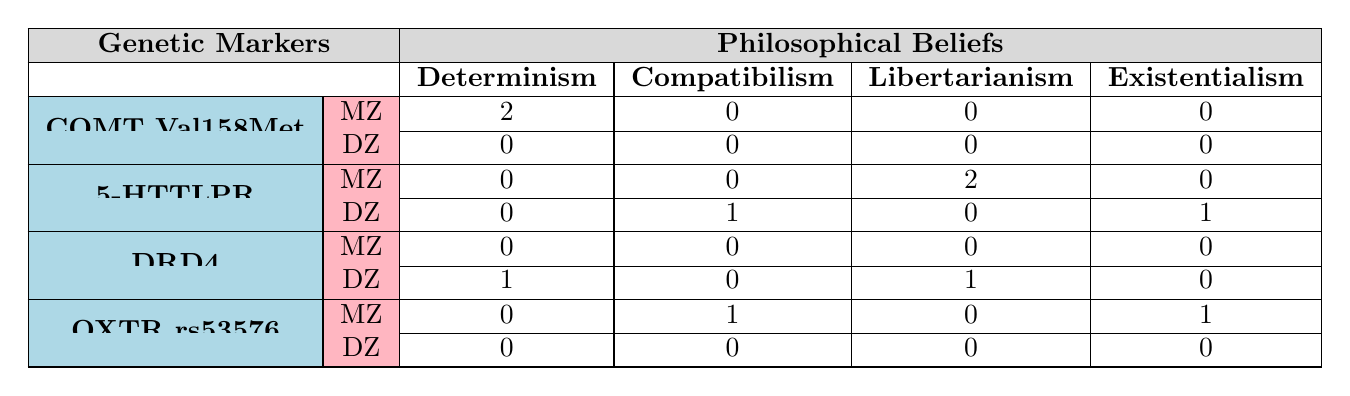What is the count of twin pairs for the genetic marker COMT Val158Met? The table shows that there are 2 twin pairs (both monozygotic) who have the philosophical belief of Determinism associated with the genetic marker COMT Val158Met.
Answer: 2 How many twin pairs subscribe to Compatibilism among twin pairs with the genetic marker OXTR rs53576? According to the table, there is 1 monozygotic twin pair that has a philosophical belief of Compatibilism with the genetic marker OXTR rs53576.
Answer: 1 What is the total number of twin pairs for the 5-HTTLPR genetic marker? The table indicates that there are 2 monozygotic twin pairs who believe in Libertarianism, and there is 1 dizygotic twin pair who holds Compatibilism and 1 who believes in Existentialism, making a total of 4 for the genetic marker 5-HTTLPR.
Answer: 4 Does any dizygotic twin pair have the same philosophical belief associated with the genetic marker DRD4? The table shows that there are no dizygotic twin pairs with the same philosophical belief associated with the genetic marker DRD4 as one holds Determinism and another holds Libertarianism.
Answer: No Which philosophical belief is most associated with monozygotic twins for the genetic marker 5-HTTLPR? The data shows that Libertarianism is the only philosophical belief reported among monozygotic twins for the genetic marker 5-HTTLPR, with 2 occurrences.
Answer: Libertarianism How many twin pairs with the genetic marker OXTR rs53576 are divided in their philosophical beliefs? For OXTR rs53576, there is 1 monozygotic twin pair divided between Compatibilism and Existentialism, showing a difference in belief.
Answer: 1 What is the relationship between genetic markers and the belief in Libertarianism across all twin pairs? Libertarianism appears twice in the monozygotic twins for the genetic marker 5-HTTLPR and once in the dizygotic twin for the marker DRD4, indicating a possible positive association, but only within the available data.
Answer: Positive association Is there any philosophical belief that is only found among dizygotic twins? The table shows that there are no philosophical beliefs exclusively found among dizygotic twins since all beliefs appear in at least one instance alongside monozygotic twins.
Answer: No What is the overall trend in philosophical beliefs between monozygotic and dizygotic twin pairs? The table indicates that monozygotic twins show more consistency in philosophical beliefs related to their genetic markers, while dizygotic twins exhibit a broader range of beliefs, suggesting a trend of belief stability among monozygotic pairs compared to dizygotic ones.
Answer: Stability among monozygotic pairs 